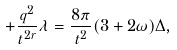<formula> <loc_0><loc_0><loc_500><loc_500>+ \frac { q ^ { 2 } } { t ^ { 2 r } } \lambda = \frac { 8 \pi } { t ^ { 2 } } ( 3 + 2 \omega ) \Delta ,</formula> 